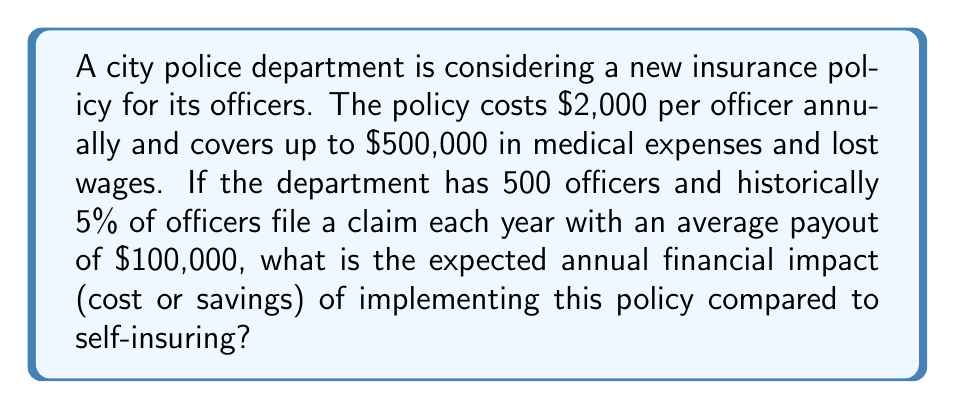What is the answer to this math problem? To solve this problem, we need to compare the cost of the new insurance policy with the expected payout if the department were to self-insure. Let's break it down step by step:

1. Calculate the total annual cost of the new insurance policy:
   $$\text{Annual policy cost} = \text{Cost per officer} \times \text{Number of officers}$$
   $$\text{Annual policy cost} = \$2,000 \times 500 = \$1,000,000$$

2. Calculate the expected annual payout if self-insuring:
   $$\text{Expected payout} = \text{Number of officers} \times \text{Claim probability} \times \text{Average claim amount}$$
   $$\text{Expected payout} = 500 \times 0.05 \times \$100,000 = \$2,500,000$$

3. Calculate the financial impact (cost or savings) by subtracting the insurance policy cost from the expected self-insurance payout:
   $$\text{Financial impact} = \text{Expected self-insurance payout} - \text{Insurance policy cost}$$
   $$\text{Financial impact} = \$2,500,000 - \$1,000,000 = \$1,500,000$$

Since the financial impact is positive, this represents an expected annual savings for the department if they implement the new insurance policy.
Answer: The expected annual financial impact of implementing the new insurance policy is a savings of $1,500,000 compared to self-insuring. 